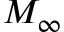<formula> <loc_0><loc_0><loc_500><loc_500>M _ { \infty }</formula> 